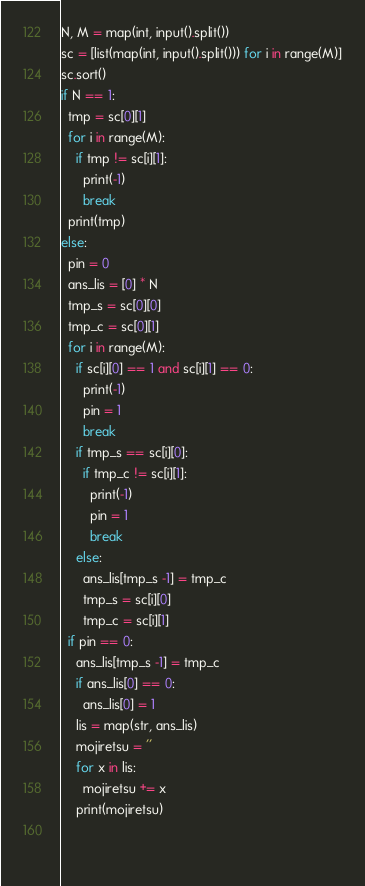Convert code to text. <code><loc_0><loc_0><loc_500><loc_500><_Python_>N, M = map(int, input().split())
sc = [list(map(int, input().split())) for i in range(M)]
sc.sort()
if N == 1:
  tmp = sc[0][1]
  for i in range(M):
    if tmp != sc[i][1]:
      print(-1)
      break
  print(tmp)
else:
  pin = 0
  ans_lis = [0] * N
  tmp_s = sc[0][0]
  tmp_c = sc[0][1]
  for i in range(M):
    if sc[i][0] == 1 and sc[i][1] == 0:
      print(-1)
      pin = 1
      break
    if tmp_s == sc[i][0]:
      if tmp_c != sc[i][1]:
        print(-1)
        pin = 1
        break
    else:
      ans_lis[tmp_s -1] = tmp_c
      tmp_s = sc[i][0]
      tmp_c = sc[i][1]
  if pin == 0:
    ans_lis[tmp_s -1] = tmp_c
    if ans_lis[0] == 0:
      ans_lis[0] = 1
    lis = map(str, ans_lis)
    mojiretsu = ''
    for x in lis:
      mojiretsu += x
    print(mojiretsu)
      
      
</code> 